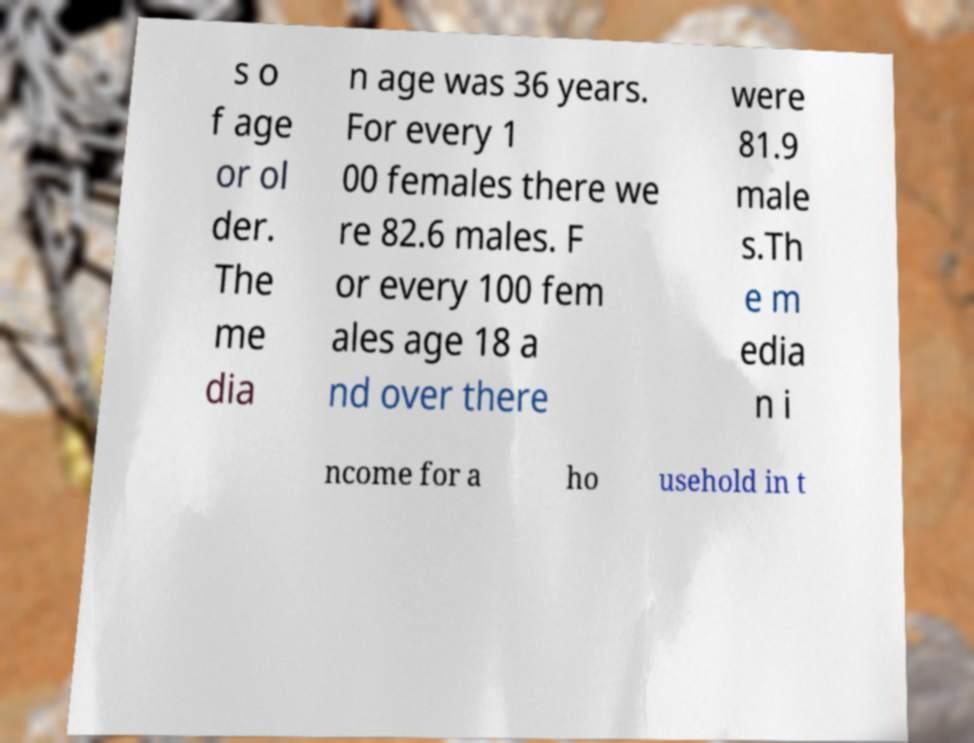I need the written content from this picture converted into text. Can you do that? s o f age or ol der. The me dia n age was 36 years. For every 1 00 females there we re 82.6 males. F or every 100 fem ales age 18 a nd over there were 81.9 male s.Th e m edia n i ncome for a ho usehold in t 